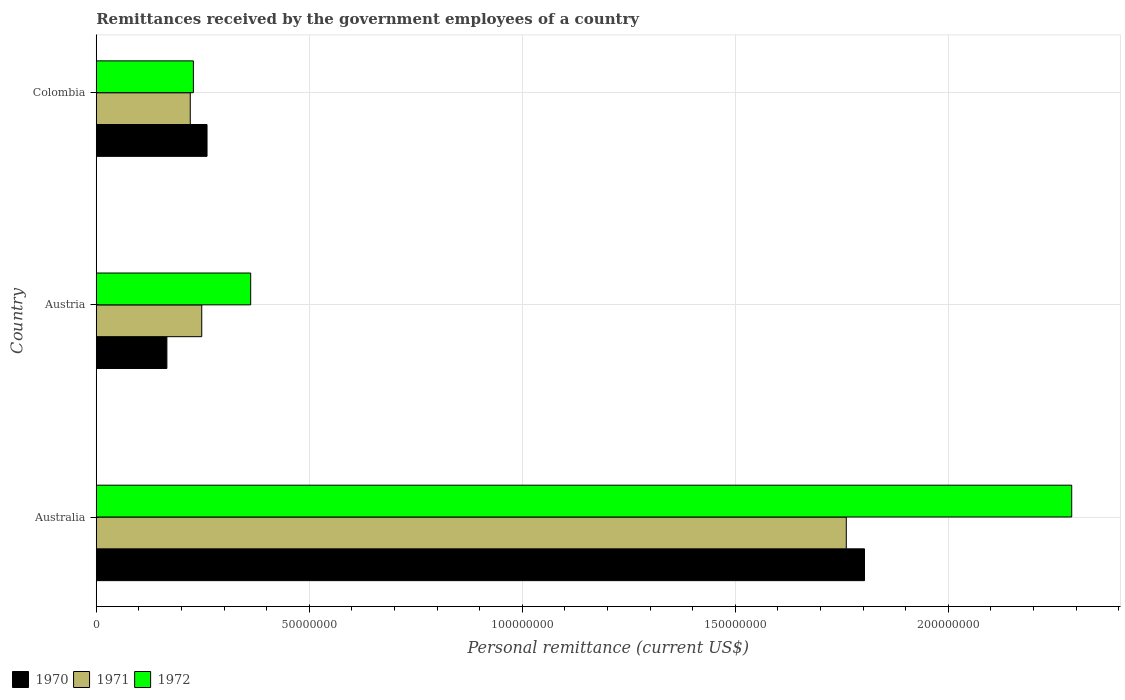How many groups of bars are there?
Offer a terse response. 3. Are the number of bars on each tick of the Y-axis equal?
Ensure brevity in your answer.  Yes. What is the label of the 3rd group of bars from the top?
Provide a succinct answer. Australia. In how many cases, is the number of bars for a given country not equal to the number of legend labels?
Give a very brief answer. 0. What is the remittances received by the government employees in 1972 in Australia?
Your answer should be very brief. 2.29e+08. Across all countries, what is the maximum remittances received by the government employees in 1972?
Keep it short and to the point. 2.29e+08. Across all countries, what is the minimum remittances received by the government employees in 1971?
Your response must be concise. 2.21e+07. In which country was the remittances received by the government employees in 1971 minimum?
Give a very brief answer. Colombia. What is the total remittances received by the government employees in 1972 in the graph?
Ensure brevity in your answer.  2.88e+08. What is the difference between the remittances received by the government employees in 1970 in Austria and that in Colombia?
Offer a very short reply. -9.42e+06. What is the difference between the remittances received by the government employees in 1972 in Australia and the remittances received by the government employees in 1971 in Austria?
Provide a succinct answer. 2.04e+08. What is the average remittances received by the government employees in 1970 per country?
Ensure brevity in your answer.  7.43e+07. What is the difference between the remittances received by the government employees in 1971 and remittances received by the government employees in 1972 in Austria?
Your answer should be very brief. -1.15e+07. In how many countries, is the remittances received by the government employees in 1970 greater than 40000000 US$?
Provide a short and direct response. 1. What is the ratio of the remittances received by the government employees in 1971 in Australia to that in Austria?
Offer a terse response. 7.11. Is the remittances received by the government employees in 1971 in Australia less than that in Colombia?
Offer a terse response. No. Is the difference between the remittances received by the government employees in 1971 in Austria and Colombia greater than the difference between the remittances received by the government employees in 1972 in Austria and Colombia?
Keep it short and to the point. No. What is the difference between the highest and the second highest remittances received by the government employees in 1972?
Provide a short and direct response. 1.93e+08. What is the difference between the highest and the lowest remittances received by the government employees in 1972?
Your response must be concise. 2.06e+08. What does the 1st bar from the bottom in Australia represents?
Make the answer very short. 1970. Is it the case that in every country, the sum of the remittances received by the government employees in 1972 and remittances received by the government employees in 1971 is greater than the remittances received by the government employees in 1970?
Your response must be concise. Yes. How many bars are there?
Offer a terse response. 9. Does the graph contain any zero values?
Keep it short and to the point. No. Where does the legend appear in the graph?
Make the answer very short. Bottom left. How many legend labels are there?
Your answer should be very brief. 3. How are the legend labels stacked?
Make the answer very short. Horizontal. What is the title of the graph?
Your answer should be very brief. Remittances received by the government employees of a country. Does "2007" appear as one of the legend labels in the graph?
Give a very brief answer. No. What is the label or title of the X-axis?
Offer a terse response. Personal remittance (current US$). What is the Personal remittance (current US$) in 1970 in Australia?
Your answer should be compact. 1.80e+08. What is the Personal remittance (current US$) of 1971 in Australia?
Keep it short and to the point. 1.76e+08. What is the Personal remittance (current US$) in 1972 in Australia?
Your response must be concise. 2.29e+08. What is the Personal remittance (current US$) of 1970 in Austria?
Your response must be concise. 1.66e+07. What is the Personal remittance (current US$) in 1971 in Austria?
Offer a very short reply. 2.48e+07. What is the Personal remittance (current US$) in 1972 in Austria?
Give a very brief answer. 3.62e+07. What is the Personal remittance (current US$) in 1970 in Colombia?
Offer a terse response. 2.60e+07. What is the Personal remittance (current US$) in 1971 in Colombia?
Ensure brevity in your answer.  2.21e+07. What is the Personal remittance (current US$) in 1972 in Colombia?
Provide a short and direct response. 2.28e+07. Across all countries, what is the maximum Personal remittance (current US$) in 1970?
Provide a short and direct response. 1.80e+08. Across all countries, what is the maximum Personal remittance (current US$) in 1971?
Keep it short and to the point. 1.76e+08. Across all countries, what is the maximum Personal remittance (current US$) of 1972?
Your answer should be compact. 2.29e+08. Across all countries, what is the minimum Personal remittance (current US$) of 1970?
Ensure brevity in your answer.  1.66e+07. Across all countries, what is the minimum Personal remittance (current US$) of 1971?
Your answer should be very brief. 2.21e+07. Across all countries, what is the minimum Personal remittance (current US$) in 1972?
Provide a short and direct response. 2.28e+07. What is the total Personal remittance (current US$) in 1970 in the graph?
Provide a succinct answer. 2.23e+08. What is the total Personal remittance (current US$) in 1971 in the graph?
Ensure brevity in your answer.  2.23e+08. What is the total Personal remittance (current US$) in 1972 in the graph?
Your answer should be compact. 2.88e+08. What is the difference between the Personal remittance (current US$) of 1970 in Australia and that in Austria?
Your response must be concise. 1.64e+08. What is the difference between the Personal remittance (current US$) of 1971 in Australia and that in Austria?
Your response must be concise. 1.51e+08. What is the difference between the Personal remittance (current US$) in 1972 in Australia and that in Austria?
Offer a terse response. 1.93e+08. What is the difference between the Personal remittance (current US$) in 1970 in Australia and that in Colombia?
Your response must be concise. 1.54e+08. What is the difference between the Personal remittance (current US$) in 1971 in Australia and that in Colombia?
Offer a terse response. 1.54e+08. What is the difference between the Personal remittance (current US$) in 1972 in Australia and that in Colombia?
Ensure brevity in your answer.  2.06e+08. What is the difference between the Personal remittance (current US$) in 1970 in Austria and that in Colombia?
Offer a very short reply. -9.42e+06. What is the difference between the Personal remittance (current US$) in 1971 in Austria and that in Colombia?
Provide a short and direct response. 2.69e+06. What is the difference between the Personal remittance (current US$) in 1972 in Austria and that in Colombia?
Your answer should be very brief. 1.34e+07. What is the difference between the Personal remittance (current US$) in 1970 in Australia and the Personal remittance (current US$) in 1971 in Austria?
Give a very brief answer. 1.56e+08. What is the difference between the Personal remittance (current US$) in 1970 in Australia and the Personal remittance (current US$) in 1972 in Austria?
Keep it short and to the point. 1.44e+08. What is the difference between the Personal remittance (current US$) of 1971 in Australia and the Personal remittance (current US$) of 1972 in Austria?
Provide a short and direct response. 1.40e+08. What is the difference between the Personal remittance (current US$) of 1970 in Australia and the Personal remittance (current US$) of 1971 in Colombia?
Give a very brief answer. 1.58e+08. What is the difference between the Personal remittance (current US$) in 1970 in Australia and the Personal remittance (current US$) in 1972 in Colombia?
Provide a short and direct response. 1.58e+08. What is the difference between the Personal remittance (current US$) in 1971 in Australia and the Personal remittance (current US$) in 1972 in Colombia?
Your answer should be very brief. 1.53e+08. What is the difference between the Personal remittance (current US$) in 1970 in Austria and the Personal remittance (current US$) in 1971 in Colombia?
Your response must be concise. -5.49e+06. What is the difference between the Personal remittance (current US$) in 1970 in Austria and the Personal remittance (current US$) in 1972 in Colombia?
Your answer should be very brief. -6.22e+06. What is the difference between the Personal remittance (current US$) of 1971 in Austria and the Personal remittance (current US$) of 1972 in Colombia?
Offer a terse response. 1.96e+06. What is the average Personal remittance (current US$) of 1970 per country?
Offer a terse response. 7.43e+07. What is the average Personal remittance (current US$) in 1971 per country?
Your response must be concise. 7.43e+07. What is the average Personal remittance (current US$) in 1972 per country?
Offer a very short reply. 9.60e+07. What is the difference between the Personal remittance (current US$) of 1970 and Personal remittance (current US$) of 1971 in Australia?
Offer a very short reply. 4.27e+06. What is the difference between the Personal remittance (current US$) of 1970 and Personal remittance (current US$) of 1972 in Australia?
Your answer should be very brief. -4.86e+07. What is the difference between the Personal remittance (current US$) of 1971 and Personal remittance (current US$) of 1972 in Australia?
Ensure brevity in your answer.  -5.29e+07. What is the difference between the Personal remittance (current US$) in 1970 and Personal remittance (current US$) in 1971 in Austria?
Provide a succinct answer. -8.18e+06. What is the difference between the Personal remittance (current US$) of 1970 and Personal remittance (current US$) of 1972 in Austria?
Offer a terse response. -1.97e+07. What is the difference between the Personal remittance (current US$) in 1971 and Personal remittance (current US$) in 1972 in Austria?
Make the answer very short. -1.15e+07. What is the difference between the Personal remittance (current US$) of 1970 and Personal remittance (current US$) of 1971 in Colombia?
Your answer should be compact. 3.93e+06. What is the difference between the Personal remittance (current US$) in 1970 and Personal remittance (current US$) in 1972 in Colombia?
Offer a very short reply. 3.20e+06. What is the difference between the Personal remittance (current US$) in 1971 and Personal remittance (current US$) in 1972 in Colombia?
Your answer should be very brief. -7.34e+05. What is the ratio of the Personal remittance (current US$) of 1970 in Australia to that in Austria?
Give a very brief answer. 10.88. What is the ratio of the Personal remittance (current US$) in 1971 in Australia to that in Austria?
Ensure brevity in your answer.  7.11. What is the ratio of the Personal remittance (current US$) in 1972 in Australia to that in Austria?
Give a very brief answer. 6.32. What is the ratio of the Personal remittance (current US$) in 1970 in Australia to that in Colombia?
Your answer should be compact. 6.94. What is the ratio of the Personal remittance (current US$) in 1971 in Australia to that in Colombia?
Your answer should be very brief. 7.98. What is the ratio of the Personal remittance (current US$) in 1972 in Australia to that in Colombia?
Keep it short and to the point. 10.04. What is the ratio of the Personal remittance (current US$) of 1970 in Austria to that in Colombia?
Give a very brief answer. 0.64. What is the ratio of the Personal remittance (current US$) in 1971 in Austria to that in Colombia?
Your answer should be compact. 1.12. What is the ratio of the Personal remittance (current US$) in 1972 in Austria to that in Colombia?
Keep it short and to the point. 1.59. What is the difference between the highest and the second highest Personal remittance (current US$) in 1970?
Provide a succinct answer. 1.54e+08. What is the difference between the highest and the second highest Personal remittance (current US$) in 1971?
Make the answer very short. 1.51e+08. What is the difference between the highest and the second highest Personal remittance (current US$) in 1972?
Offer a very short reply. 1.93e+08. What is the difference between the highest and the lowest Personal remittance (current US$) in 1970?
Offer a terse response. 1.64e+08. What is the difference between the highest and the lowest Personal remittance (current US$) in 1971?
Keep it short and to the point. 1.54e+08. What is the difference between the highest and the lowest Personal remittance (current US$) in 1972?
Keep it short and to the point. 2.06e+08. 